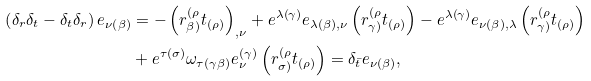<formula> <loc_0><loc_0><loc_500><loc_500>\left ( \delta _ { r } \delta _ { t } - \delta _ { t } \delta _ { r } \right ) e _ { \nu \left ( \beta \right ) } & = - \left ( r _ { \beta ) } ^ { ( \rho } t _ { \left ( \rho \right ) } \right ) _ { , \nu } + e ^ { \lambda \left ( \gamma \right ) } e _ { \lambda \left ( \beta \right ) , \nu } \left ( r _ { \gamma ) } ^ { ( \rho } t _ { \left ( \rho \right ) } \right ) - e ^ { \lambda \left ( \gamma \right ) } e _ { \nu \left ( \beta \right ) , \lambda } \left ( r _ { \gamma ) } ^ { ( \rho } t _ { \left ( \rho \right ) } \right ) \\ & + e ^ { \tau \left ( \sigma \right ) } \omega _ { \tau \left ( \gamma \beta \right ) } e _ { \nu } ^ { \left ( \gamma \right ) } \left ( r _ { \sigma ) } ^ { ( \rho } t _ { \left ( \rho \right ) } \right ) = \delta _ { \bar { t } } e _ { \nu \left ( \beta \right ) } ,</formula> 